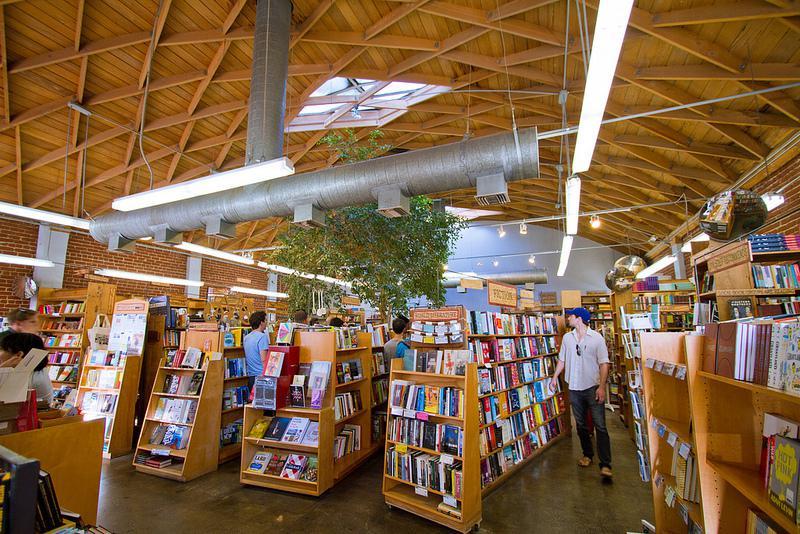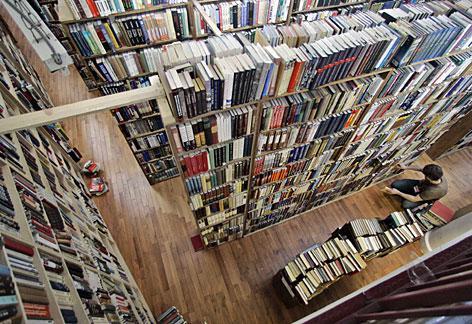The first image is the image on the left, the second image is the image on the right. For the images shown, is this caption "In the bookstore there is a single green plant hanging from the brown triangle roof pattern." true? Answer yes or no. Yes. The first image is the image on the left, the second image is the image on the right. Examine the images to the left and right. Is the description "Green foliage is hanging over bookshelves in a shop with diamond shapes in light wood on the upper part." accurate? Answer yes or no. Yes. 